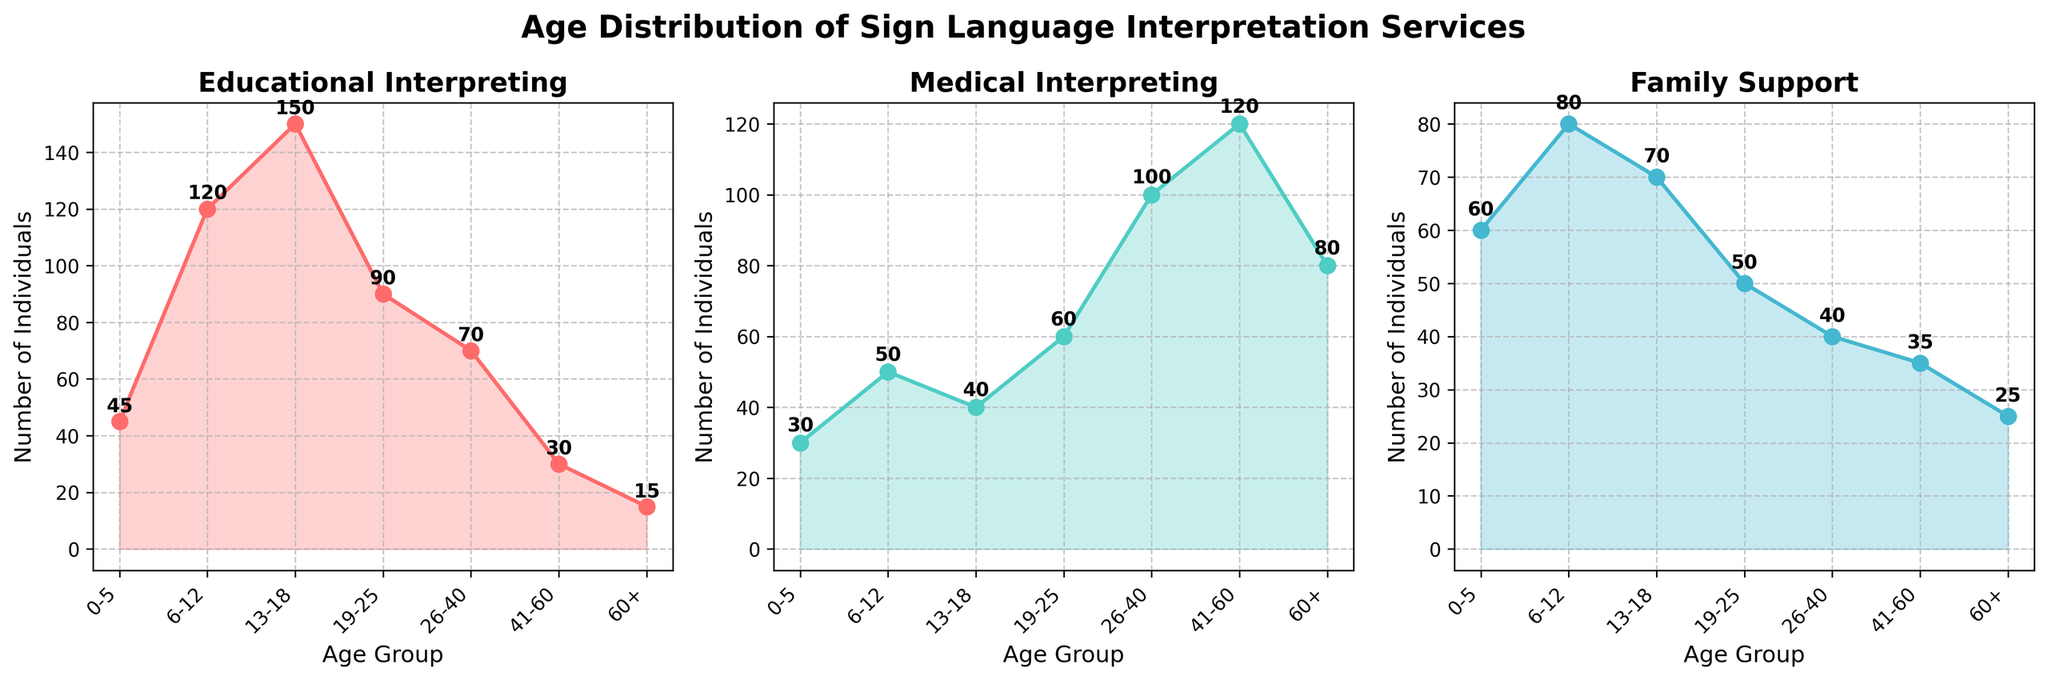What is the title of the figure? The title of the figure is located at the top and provides an overview of what the figure represents. The title reads "Age Distribution of Sign Language Interpretation Services".
Answer: Age Distribution of Sign Language Interpretation Services What are the age groups displayed on the x-axis? The age groups are indicated on the x-axis, and the x-axis labels for each subplot can be read to identify the groups. The age groups are "0-5", "6-12", "13-18", "19-25", "26-40", "41-60", and "60+".
Answer: 0-5, 6-12, 13-18, 19-25, 26-40, 41-60, 60+ Which service type has the highest count for the age group 13-18? By looking at the subplot for each service type, we can find the highest peak for the age group 13-18. The Educational Interpreting plot has the highest peak at the age group 13-18 with a count of 150.
Answer: Educational Interpreting How many individuals aged 0-5 seek Family Support services? Referring to the subplot for Family Support, we locate the age group 0-5 and find the data label indicating the count of individuals. The count for the 0-5 age group is 60.
Answer: 60 Which service type has the lowest count for the age group 41-60? By comparing the three subplots for the age group 41-60, Educational Interpreting has the lowest count in that age group, which is 30.
Answer: Educational Interpreting What is the total count of individuals seeking Medical Interpreting services across all age groups? The counts for Medical Interpreting in each age group are summed: 30 (0-5) + 50 (6-12) + 40 (13-18) + 60 (19-25) + 100 (26-40) + 120 (41-60) + 80 (60+). This gives a total of 480.
Answer: 480 Which age group has the highest number of individuals seeking Family Support services? By examining the subplot for Family Support, the highest number can be found at the age group 0-5 with a count of 60.
Answer: 0-5 Compare the number of individuals seeking Educational Interpreting and Medical Interpreting in the age group 6-12. Check the counts for each service in the age group 6-12: Educational Interpreting has 120 and Medical Interpreting has 50.
Answer: Educational Interpreting: 120, Medical Interpreting: 50 Which age group has a higher count for Medical Interpreting: 19-25 or 26-40? By comparing the counts in the Medical Interpreting subplot, the 19-25 group has 60, and the 26-40 group has 100. Thus, the 26-40 group has a higher count.
Answer: 26-40 